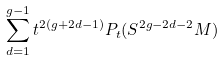<formula> <loc_0><loc_0><loc_500><loc_500>\sum _ { d = 1 } ^ { g - 1 } t ^ { 2 ( g + 2 d - 1 ) } P _ { t } ( S ^ { 2 g - 2 d - 2 } M )</formula> 